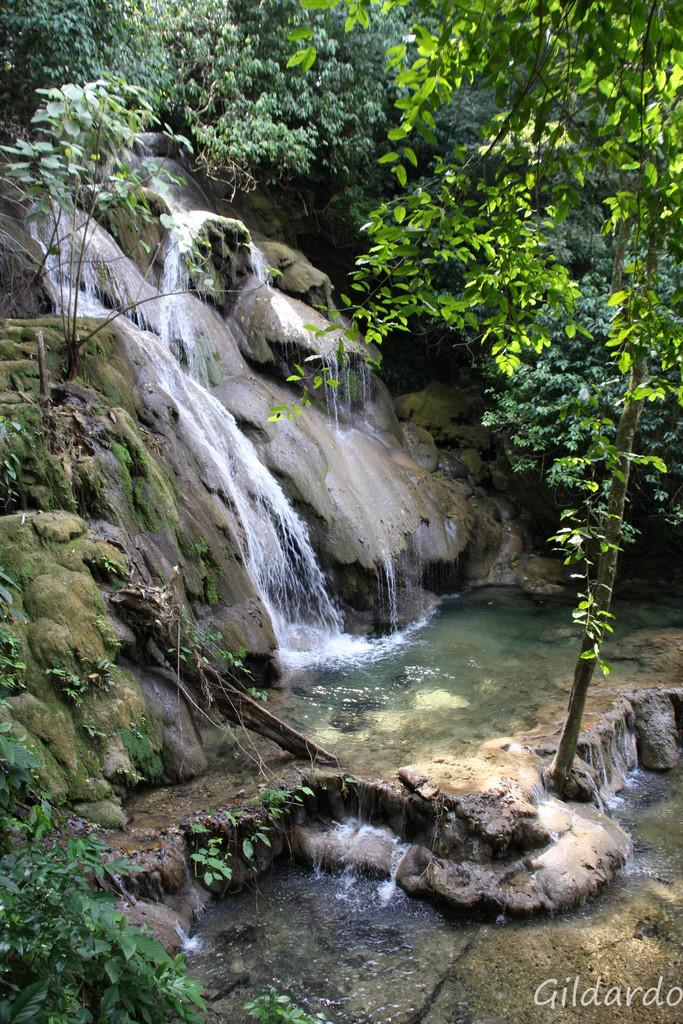What is the main feature in the center of the image? There is a waterfall in the center of the image. What else can be seen in the image besides the waterfall? There are rocks and plants visible in the image. What is located in the background of the image? There is a group of trees in the background of the image. Can you describe the volcano erupting in the image? There is no volcano present in the image; it features a waterfall, rocks, plants, and a group of trees in the background. How does the image make you feel? The image itself does not have the ability to make someone feel a certain way, as it is a static representation of a scene. 